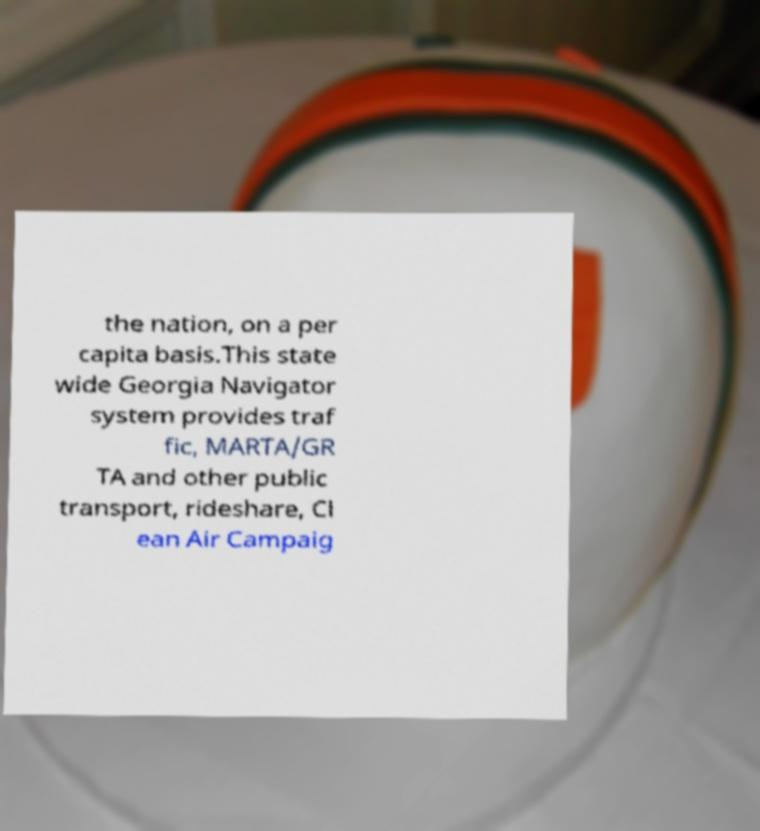Could you assist in decoding the text presented in this image and type it out clearly? the nation, on a per capita basis.This state wide Georgia Navigator system provides traf fic, MARTA/GR TA and other public transport, rideshare, Cl ean Air Campaig 